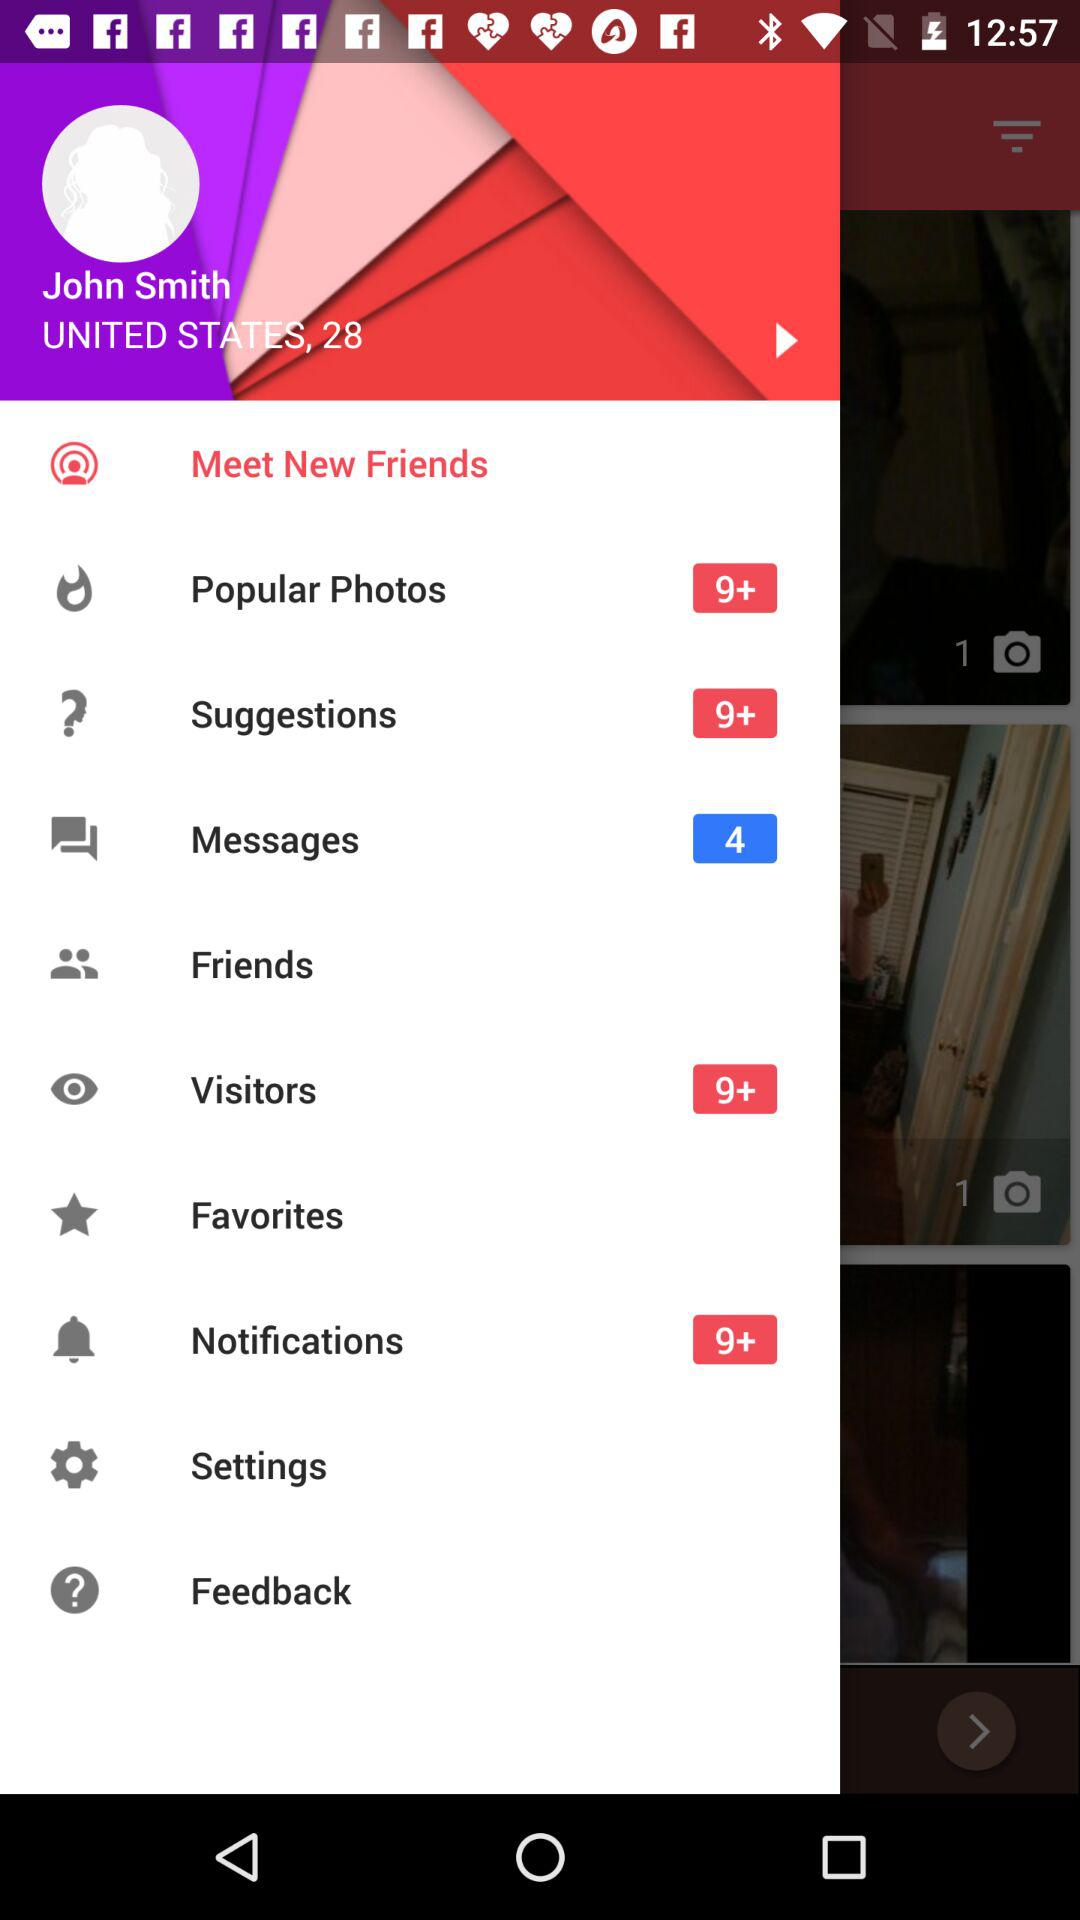How many suggestions are there? There are more than 9 suggestions. 